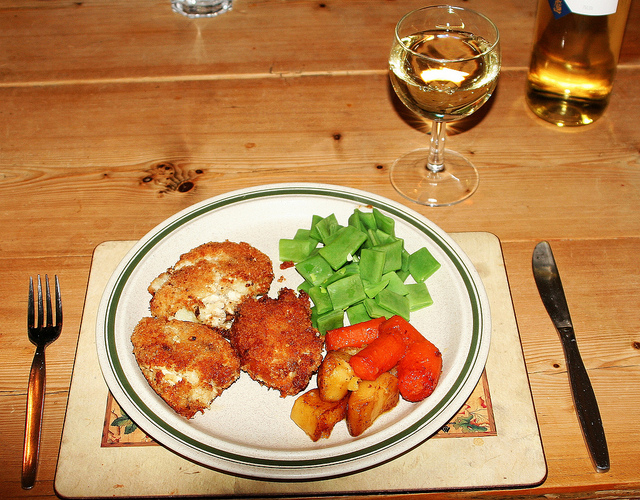<image>What might the eater of this meal be planning to do while eating? It is unknown what the eater of this meal might be planning to do while eating. What might the eater of this meal be planning to do while eating? I don't know what the eater of this meal might be planning to do while eating. They could be sitting, drinking, or celebrating Chanukah. 